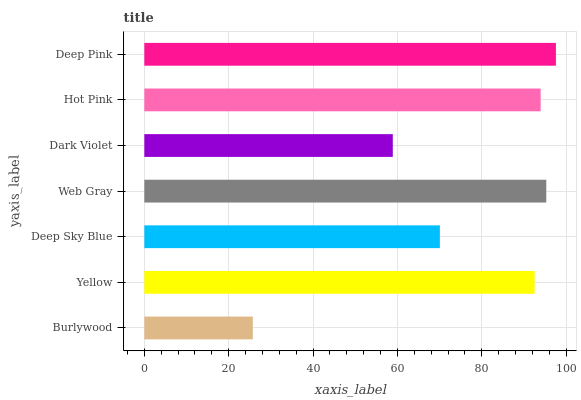Is Burlywood the minimum?
Answer yes or no. Yes. Is Deep Pink the maximum?
Answer yes or no. Yes. Is Yellow the minimum?
Answer yes or no. No. Is Yellow the maximum?
Answer yes or no. No. Is Yellow greater than Burlywood?
Answer yes or no. Yes. Is Burlywood less than Yellow?
Answer yes or no. Yes. Is Burlywood greater than Yellow?
Answer yes or no. No. Is Yellow less than Burlywood?
Answer yes or no. No. Is Yellow the high median?
Answer yes or no. Yes. Is Yellow the low median?
Answer yes or no. Yes. Is Deep Sky Blue the high median?
Answer yes or no. No. Is Deep Pink the low median?
Answer yes or no. No. 